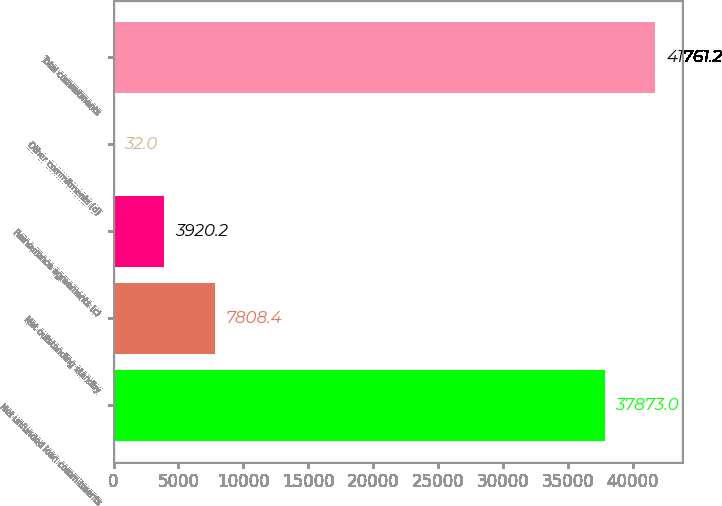<chart> <loc_0><loc_0><loc_500><loc_500><bar_chart><fcel>Net unfunded loan commitments<fcel>Net outstanding standby<fcel>Reinsurance agreements (c)<fcel>Other commitments (d)<fcel>Total commitments<nl><fcel>37873<fcel>7808.4<fcel>3920.2<fcel>32<fcel>41761.2<nl></chart> 